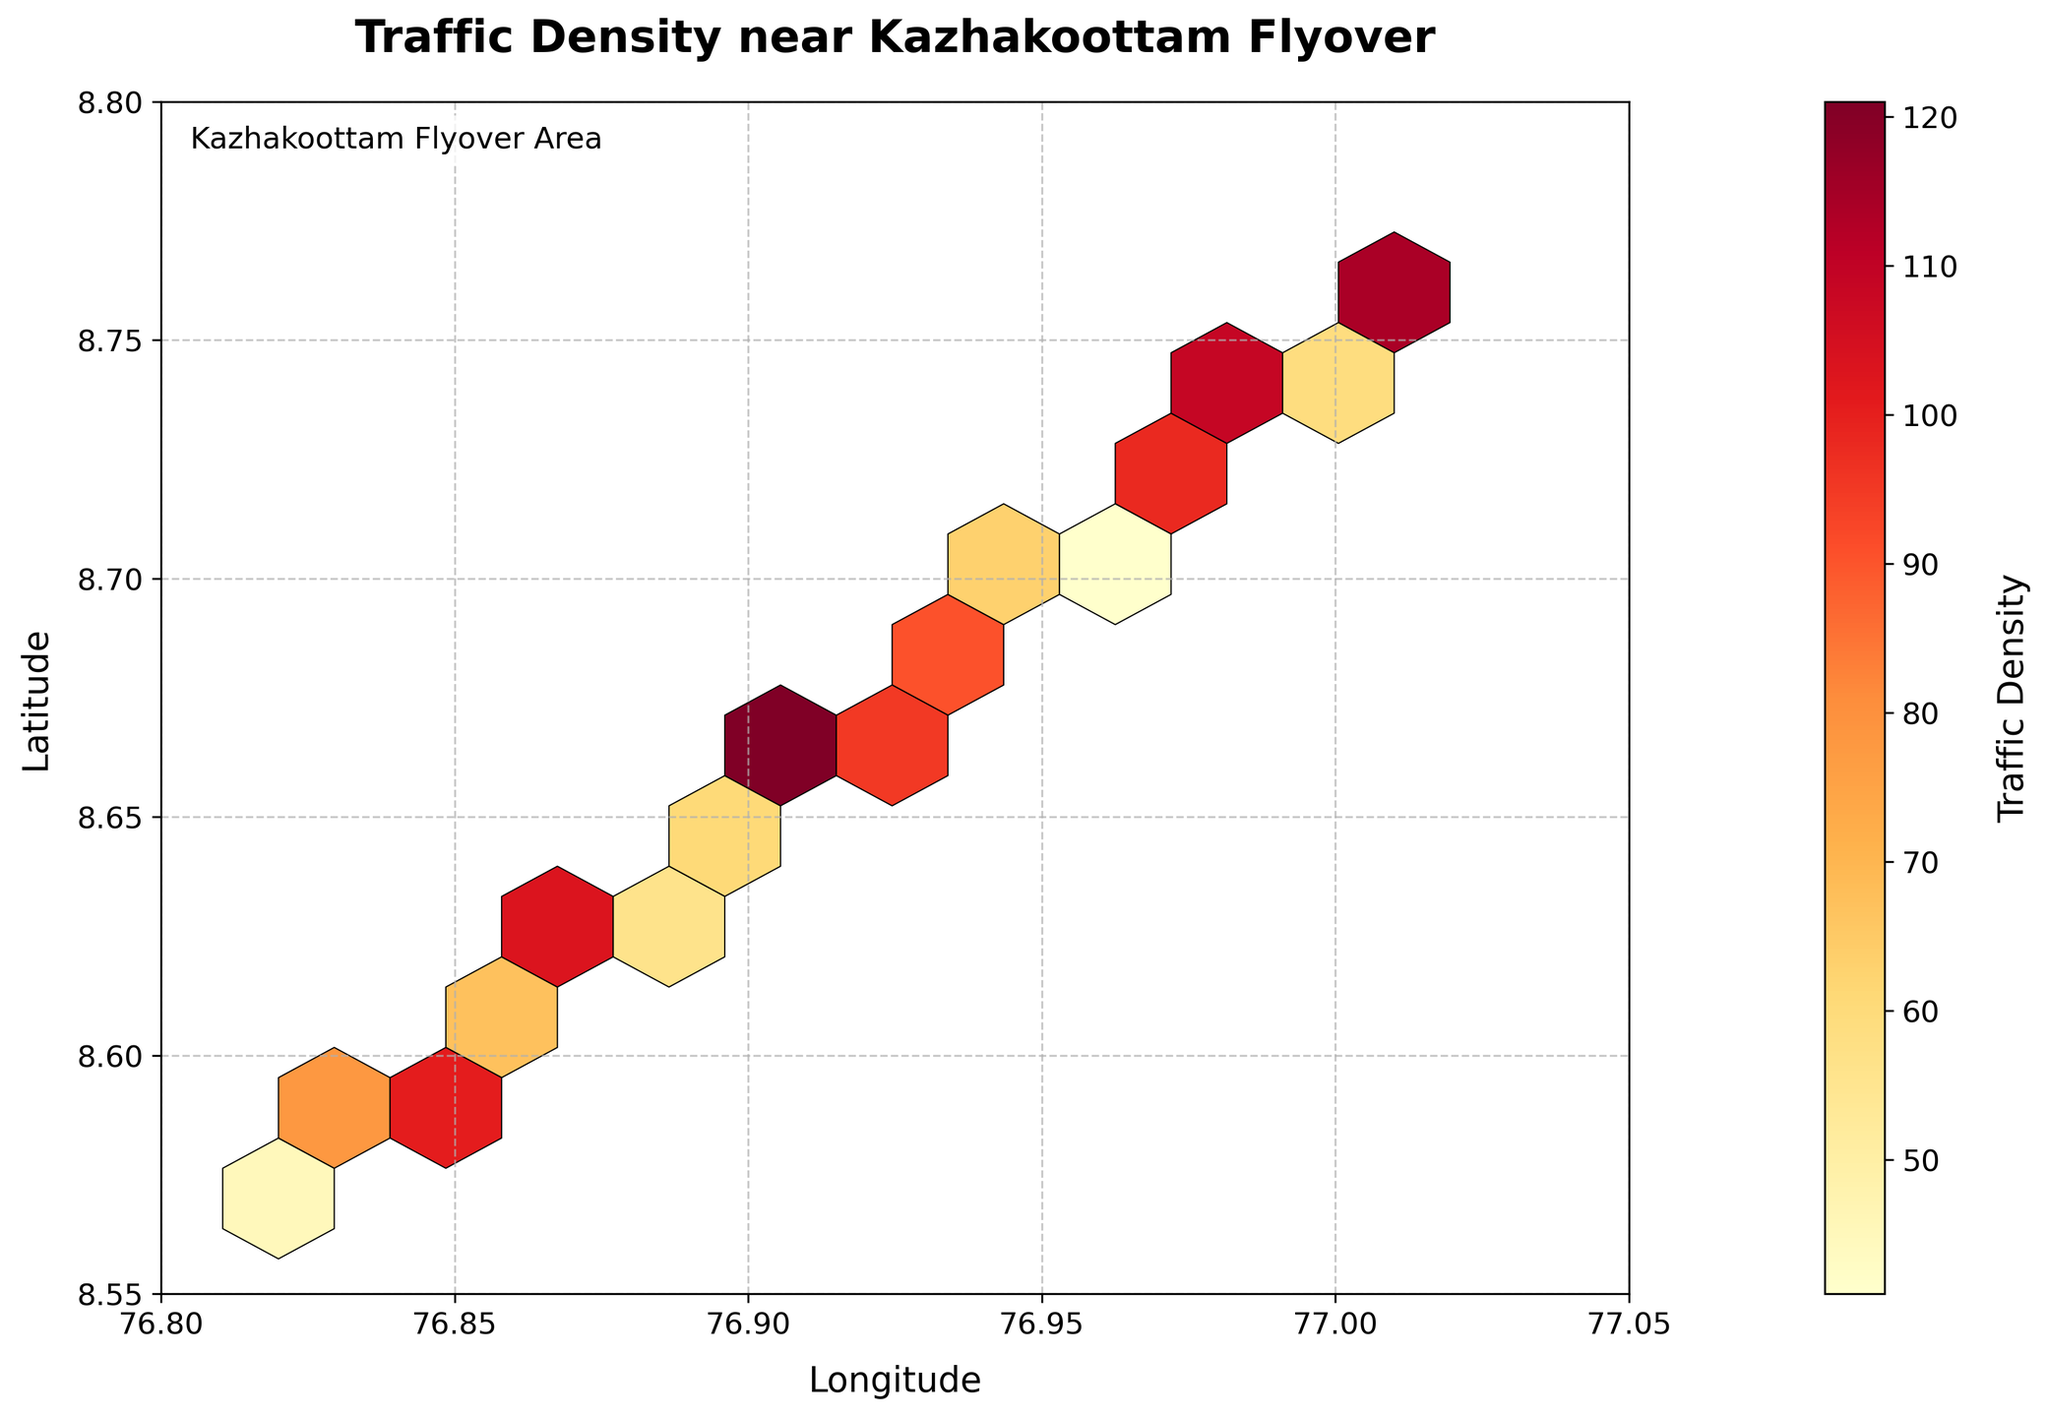What is the title of the hexbin plot? The title of the plot is displayed prominently at the top of the figure. Here, it reads "Traffic Density near Kazhakoottam Flyover".
Answer: Traffic Density near Kazhakoottam Flyover What does the color bar represent in the figure? The color bar located beside the hexbin plot indicates the range of traffic density values, with colors transitioning from lighter to darker shades representing different densities.
Answer: Traffic Density What are the latitude and longitude ranges displayed in the hexbin plot? The x-axis represents longitude, ranging from 76.8 to 77.05, and the y-axis represents latitude, ranging from 8.55 to 8.8. These ranges are defined on the axes of the plot.
Answer: Longitude: 76.8 to 77.05, Latitude: 8.55 to 8.8 Which area has the highest traffic density based on color? The color that represents the highest density is the darkest shade of red, which is located around the coordinates closest to 76.98 longitude and 8.73 latitude.
Answer: 76.98, 8.73 What traffic density value corresponds to the darkest shade on the color bar? The darkest shade on the color bar corresponds to the highest traffic density value in the dataset, which is 132. This value can be seen next to the darkest color on the color bar.
Answer: 132 Are there any specific areas with very low traffic density? Areas with very light colors or near white represent the lowest traffic density. For instance, the area around coordinates 76.89 longitude and 8.64 latitude has a low density value represented by a lighter color.
Answer: Yes, around 76.89, 8.64 Is there a noticeable trend in traffic density along the longitude or latitude? Examining the plot, one can observe that traffic density tends to be higher around the central range of longitudes (76.95 to 76.98) and drops off towards the edges. Similarly, densities are higher in the middle latitudinal range and reduce towards the northern and southern ends.
Answer: Yes, higher density in central ranges Does any region along the edges of the plotted area show high traffic density? No, regions along the edges of the hexbin plot (both in longitude and latitude) generally display lower traffic densities, as indicated by the lighter colors.
Answer: No Which area has a relatively moderate traffic density? A moderate traffic density, represented by mid-range colors like orange, is seen around coordinates 76.87 longitude and 8.62 latitude.
Answer: 76.87, 8.62 